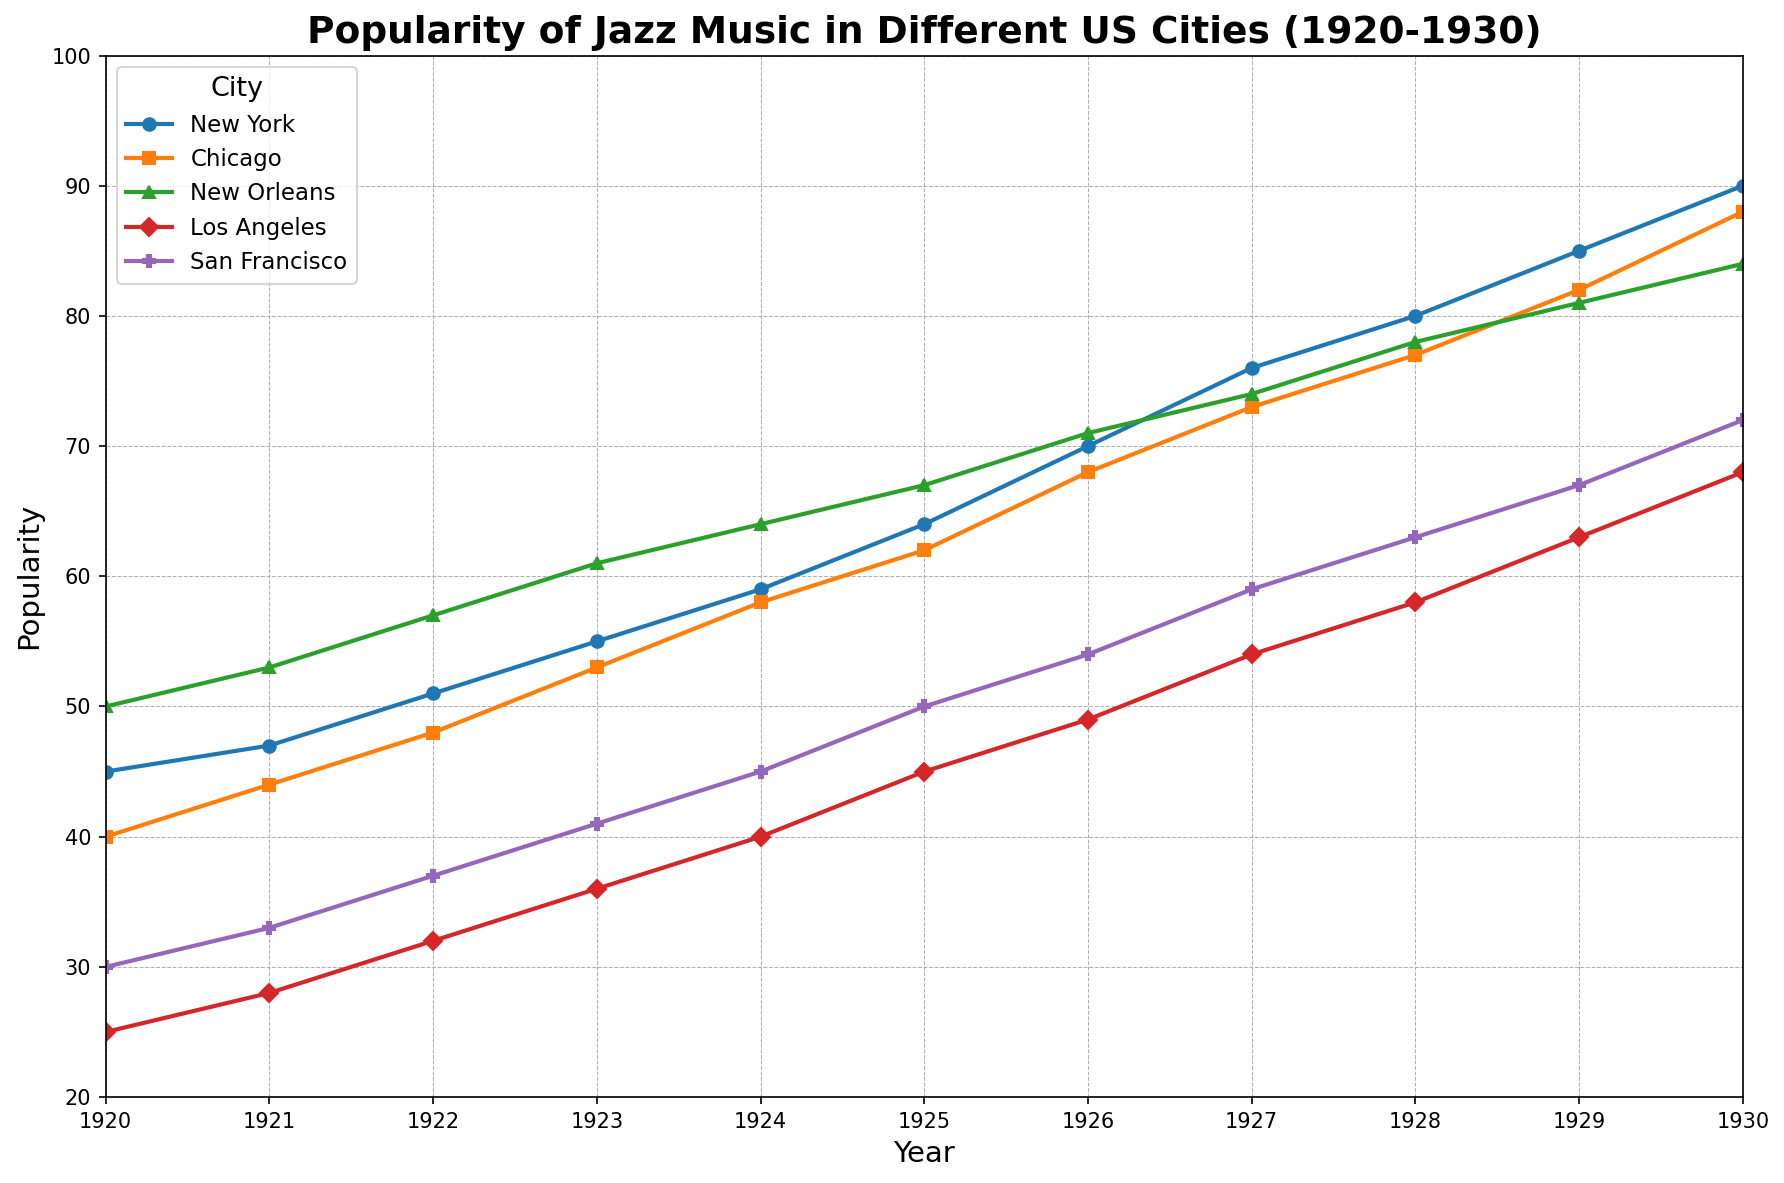Which city had the highest popularity of jazz music in 1930? Look at the popularity values for each city in the year 1930. New York has a popularity of 90, Chicago has 88, New Orleans has 84, Los Angeles has 68, and San Francisco has 72.
Answer: New York Which city experienced the greatest increase in jazz music popularity between 1920 and 1930? Calculate the difference in popularity between 1920 and 1930 for each city. New York: 90-45=45, Chicago: 88-40=48, New Orleans: 84-50=34, Los Angeles: 68-25=43, San Francisco: 72-30=42. The greatest increase is 48 for Chicago.
Answer: Chicago Between 1925 and 1930, which city saw the smallest increase in jazz music popularity? Calculate the increase in popularity for each city from 1925 to 1930. New York: 90-64=26, Chicago: 88-62=26, New Orleans: 84-67=17, Los Angeles: 68-45=23, San Francisco: 72-50=22. The smallest increase is 17 for New Orleans.
Answer: New Orleans At which year did New York surpass 70 in popularity? Look at the popularity values for New York over the years. In 1926, New York's popularity reaches 70.
Answer: 1926 Compare the trend of jazz popularity in Los Angeles and San Francisco. Which city had a steeper increase? Look at the slopes of the lines representing Los Angeles and San Francisco. Los Angeles has an increase from 25 to 68 (43 points) whereas San Francisco increases from 30 to 72 (42 points). Los Angeles has a slightly steeper increase.
Answer: Los Angeles Which city had a constant increase in popularity without any dips or plateaus from 1920 to 1930? Look for a line that continuously goes up without any dips or flat sections. All the cities show a constant increase.
Answer: All cities Between 1927 and 1928, which city had the largest increase in jazz popularity? Calculate the increase for each city between 1927 and 1928. New York: 80-76=4, Chicago: 77-73=4, New Orleans: 78-74=4, Los Angeles: 58-54=4, San Francisco: 63-59=4. All cities had an equal increase of 4.
Answer: All cities (equal increase) Which city's popularity line is represented by a triangle marker? Look at the legend in the figure to identify markers. San Francisco is represented by a triangle marker.
Answer: San Francisco In which year did New Orleans' popularity first surpass 60? Examine the data points for New Orleans. In 1923, New Orleans' popularity reaches 61.
Answer: 1923 What is the average popularity of jazz music in Chicago from 1920 to 1930? Sum the popularity values for Chicago from 1920 to 1930 and divide by the number of years (11). (40+44+48+53+58+62+68+73+77+82+88)/11 = 651/11 = 59.18.
Answer: 59.18 